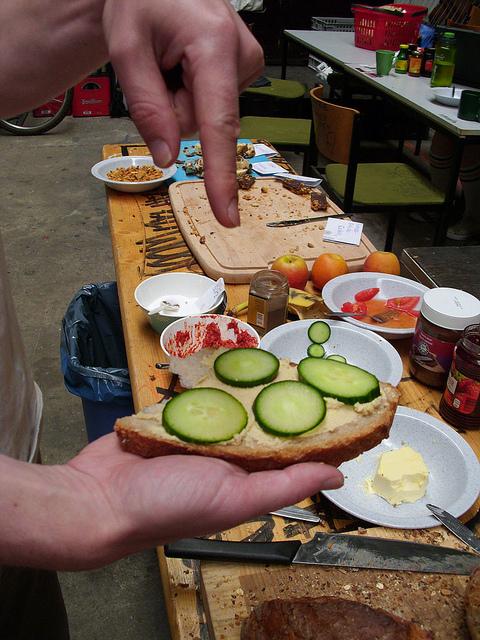How many plates are over the table?
Answer briefly. 5. Why is the person pointing at the sandwich?
Quick response, please. To show cucumbers. How many knives on the table?
Keep it brief. 3. What are the green vegetables on the plate?
Keep it brief. Cucumbers. Do these hands both belong to the same person?
Be succinct. Yes. What is the person holding in their hand?
Short answer required. Sandwich. 